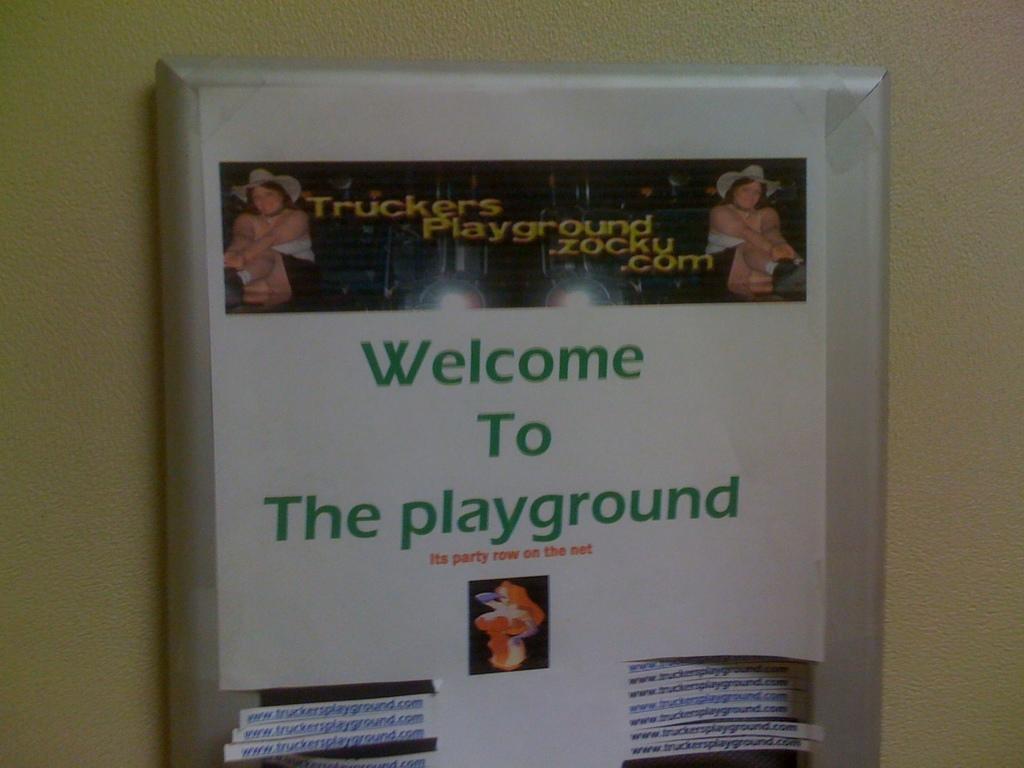What is the ad promoting?
Make the answer very short. Truckers playground. Where is this?
Your response must be concise. The playground. 